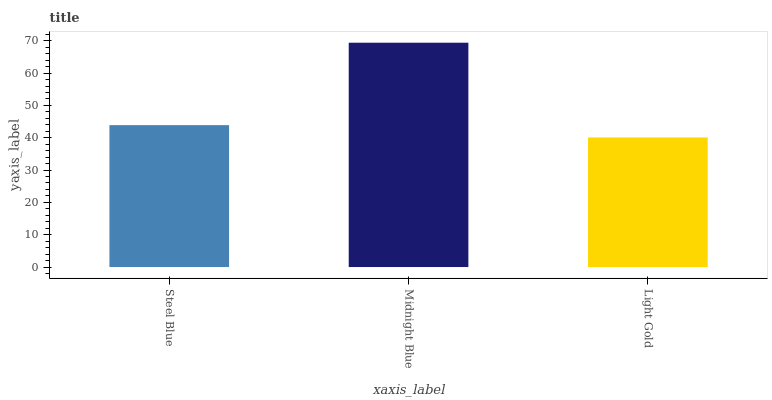Is Light Gold the minimum?
Answer yes or no. Yes. Is Midnight Blue the maximum?
Answer yes or no. Yes. Is Midnight Blue the minimum?
Answer yes or no. No. Is Light Gold the maximum?
Answer yes or no. No. Is Midnight Blue greater than Light Gold?
Answer yes or no. Yes. Is Light Gold less than Midnight Blue?
Answer yes or no. Yes. Is Light Gold greater than Midnight Blue?
Answer yes or no. No. Is Midnight Blue less than Light Gold?
Answer yes or no. No. Is Steel Blue the high median?
Answer yes or no. Yes. Is Steel Blue the low median?
Answer yes or no. Yes. Is Light Gold the high median?
Answer yes or no. No. Is Midnight Blue the low median?
Answer yes or no. No. 